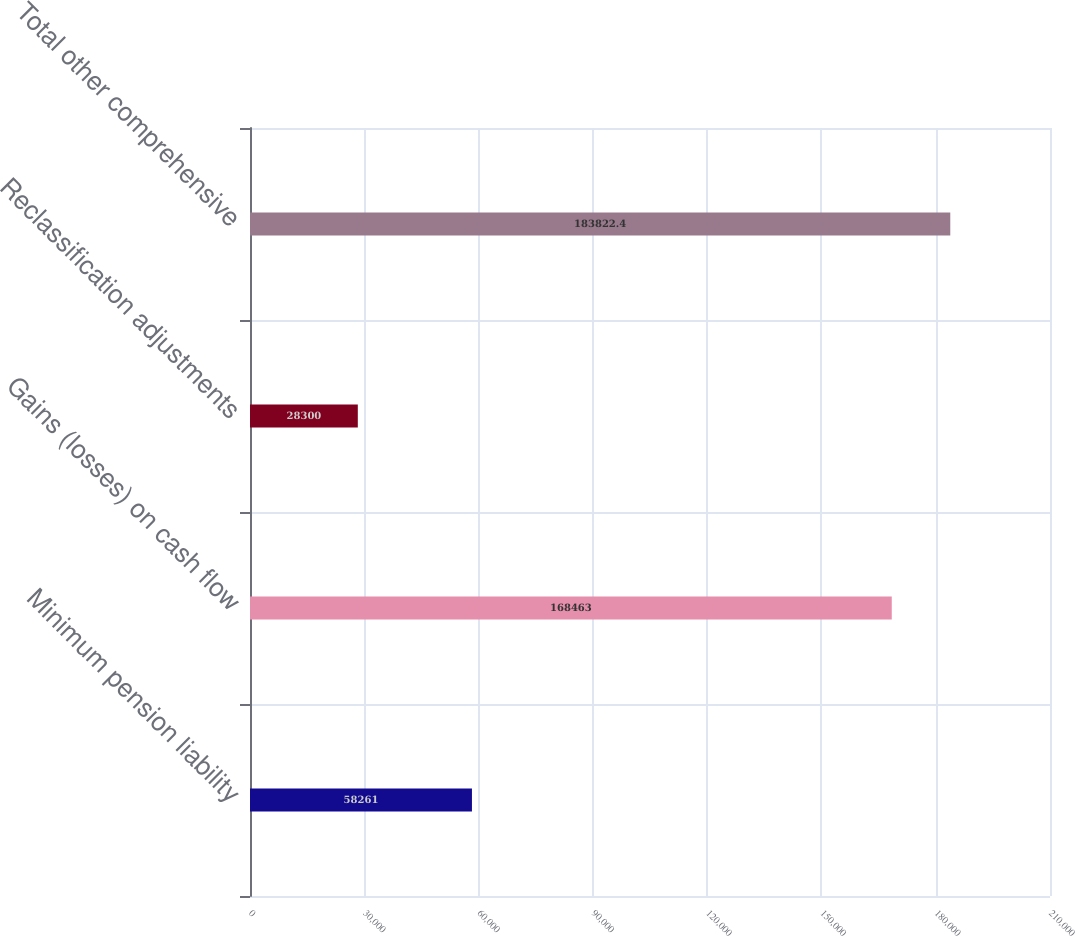Convert chart to OTSL. <chart><loc_0><loc_0><loc_500><loc_500><bar_chart><fcel>Minimum pension liability<fcel>Gains (losses) on cash flow<fcel>Reclassification adjustments<fcel>Total other comprehensive<nl><fcel>58261<fcel>168463<fcel>28300<fcel>183822<nl></chart> 